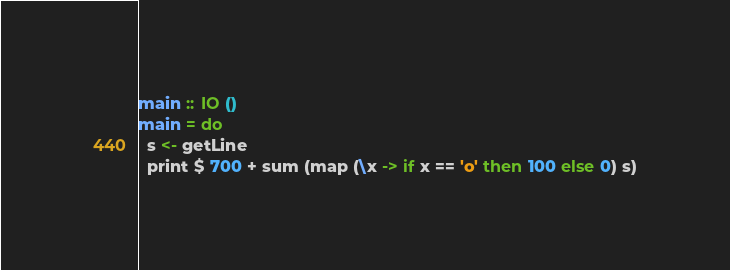Convert code to text. <code><loc_0><loc_0><loc_500><loc_500><_Haskell_>main :: IO ()
main = do
  s <- getLine
  print $ 700 + sum (map (\x -> if x == 'o' then 100 else 0) s)</code> 